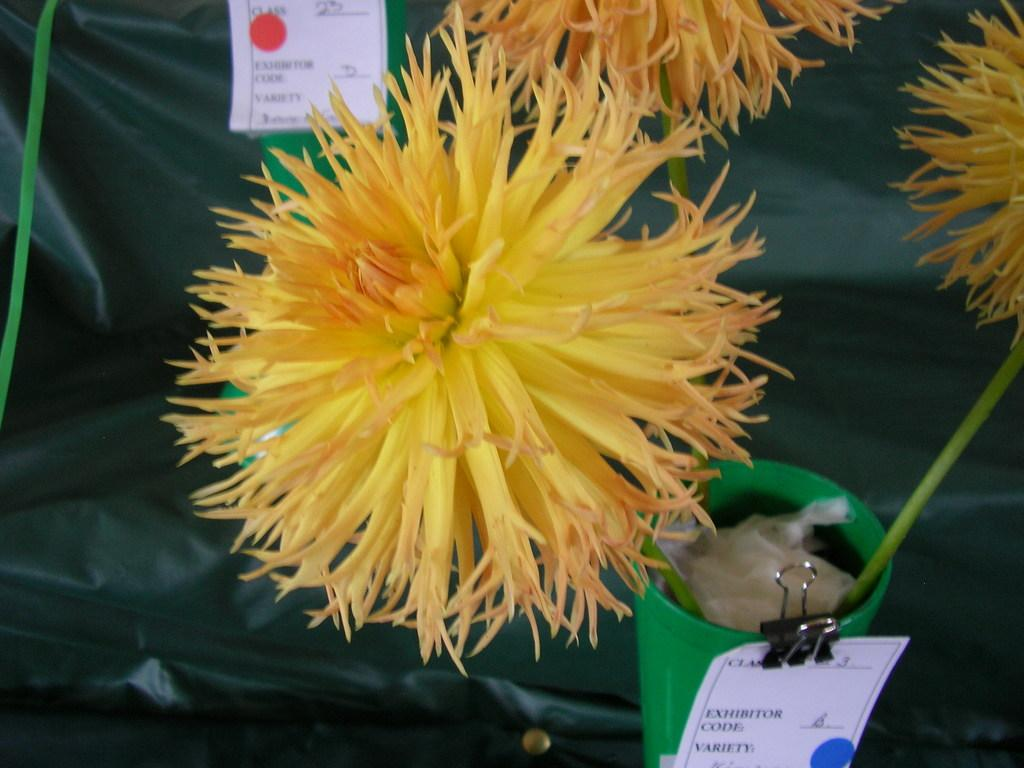What type of flowers can be seen in the image? There are yellow flowers in the image. What type of headwear is present in the image? There are caps in the image. What type of stationery items are present in the image? There are papers in the image. What type of fastener is present in the image? There is a clip in the image. How many bananas are hanging from the clip in the image? There are no bananas present in the image. What direction is the screw pointing in the image? There is no screw present in the image. 